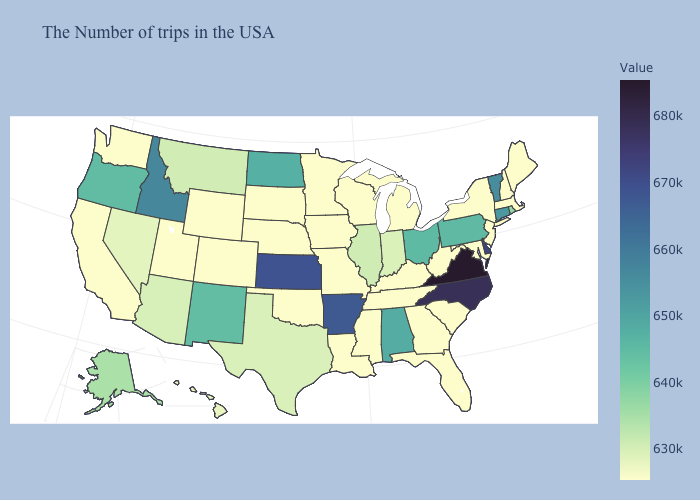Which states have the lowest value in the West?
Answer briefly. Wyoming, Colorado, Utah, California, Washington. Among the states that border Arizona , which have the highest value?
Concise answer only. New Mexico. Does Minnesota have a higher value than Rhode Island?
Answer briefly. No. Which states have the lowest value in the South?
Give a very brief answer. Maryland, South Carolina, West Virginia, Florida, Georgia, Kentucky, Tennessee, Mississippi, Louisiana, Oklahoma. 